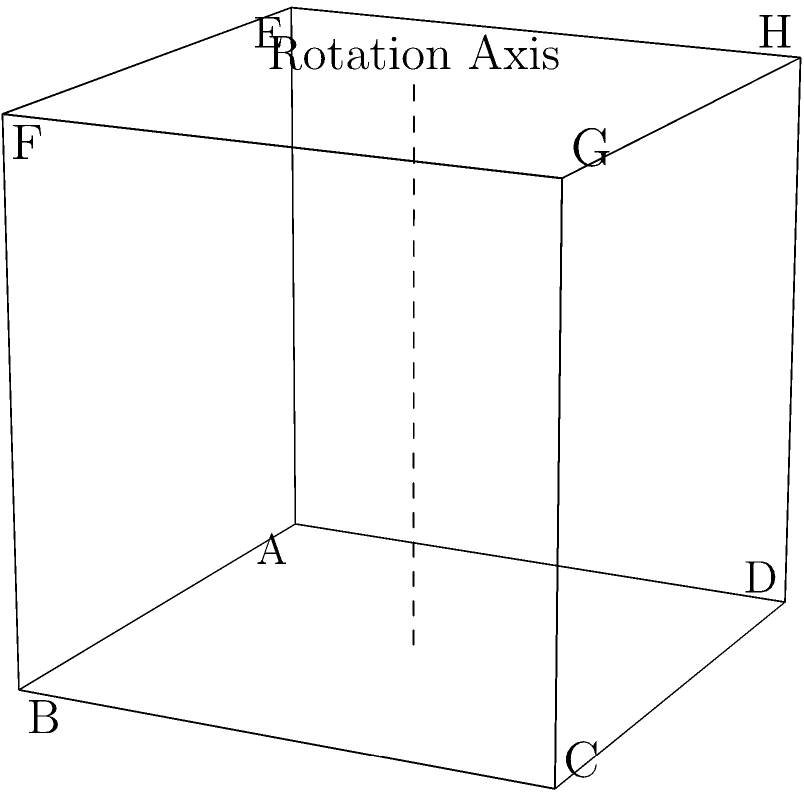As a behavioral psychologist studying the relationship between rewards and behavior, you're developing a spatial intelligence test. One question involves a cube rotation task. The cube above is rotated 90 degrees clockwise around the vertical axis passing through its center. After rotation, which face will be directly opposite to face ABCD? To solve this problem, let's follow these steps:

1. Identify the current faces of the cube:
   - Front face: ABCD
   - Back face: EFGH
   - Top face: DCGH
   - Bottom face: ABEF
   - Left face: ADHE
   - Right face: BCGF

2. Understand the rotation:
   - The cube is rotated 90 degrees clockwise around the vertical axis passing through its center.
   - This means the front face will become the right face, the right face will become the back face, the back face will become the left face, and the left face will become the front face.
   - The top and bottom faces will remain in the same position but will rotate.

3. Analyze the rotation:
   - The front face ABCD will become the right face.
   - The face opposite to the new right face (ABCD) will be the new left face.

4. Determine the new left face:
   - Before rotation, the left face was ADHE.
   - After a 90-degree clockwise rotation, this face will become the front face.

Therefore, after rotation, the face directly opposite to ABCD will be EFGH, which was originally the back face.

This spatial reasoning task is relevant to behavioral psychology as it tests cognitive abilities and problem-solving skills, which can be influenced by reward systems and behavioral conditioning.
Answer: EFGH 